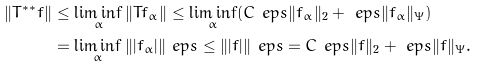Convert formula to latex. <formula><loc_0><loc_0><loc_500><loc_500>\| T ^ { \ast \ast } f \| & \leq \liminf _ { \alpha } \| T f _ { \alpha } \| \leq \liminf _ { \alpha } ( C _ { \ } e p s \| f _ { \alpha } \| _ { 2 } + \ e p s \| f _ { \alpha } \| _ { \Psi } ) \\ & = \liminf _ { \alpha } \| | f _ { \alpha } | \| _ { \ } e p s \leq \| | f | \| _ { \ } e p s = C _ { \ } e p s \| f \| _ { 2 } + \ e p s \| f \| _ { \Psi } .</formula> 